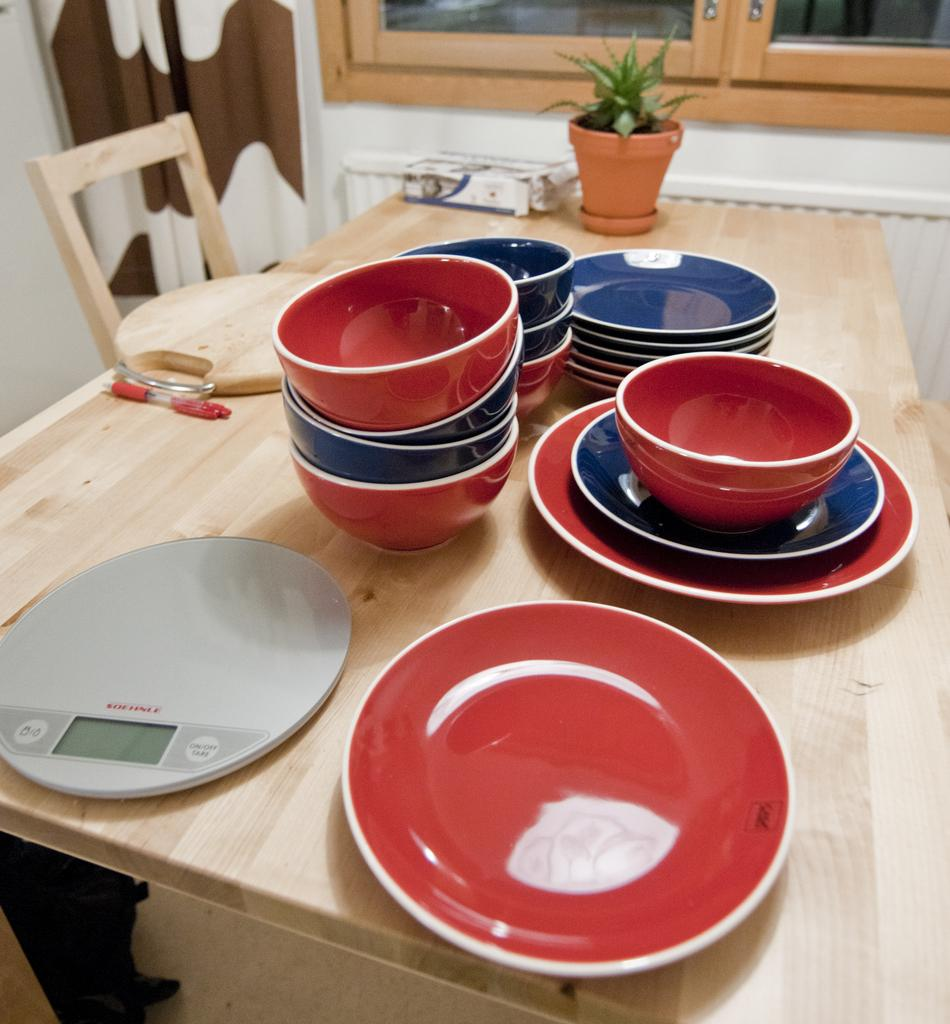<image>
Describe the image concisely. A grey Soehnle scale is on a wooden table. 